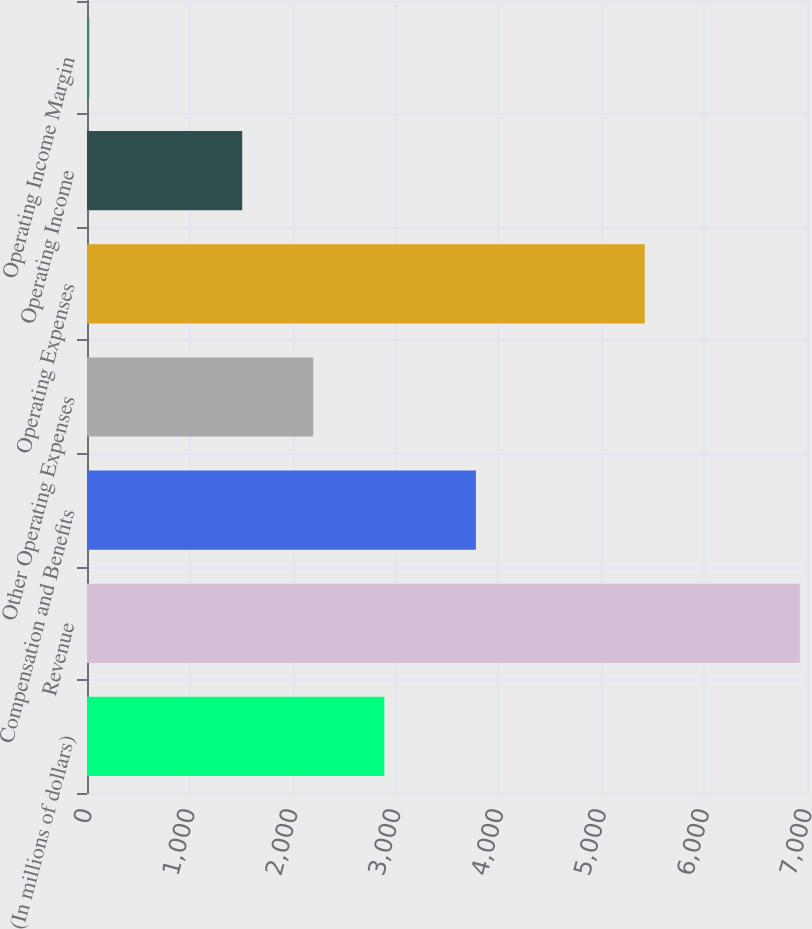Convert chart to OTSL. <chart><loc_0><loc_0><loc_500><loc_500><bar_chart><fcel>(In millions of dollars)<fcel>Revenue<fcel>Compensation and Benefits<fcel>Other Operating Expenses<fcel>Operating Expenses<fcel>Operating Income<fcel>Operating Income Margin<nl><fcel>2890.84<fcel>6931<fcel>3781<fcel>2199.92<fcel>5422<fcel>1509<fcel>21.8<nl></chart> 